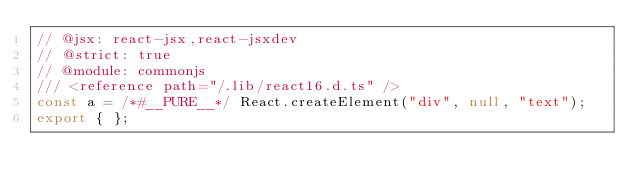<code> <loc_0><loc_0><loc_500><loc_500><_JavaScript_>// @jsx: react-jsx,react-jsxdev
// @strict: true
// @module: commonjs
/// <reference path="/.lib/react16.d.ts" />
const a = /*#__PURE__*/ React.createElement("div", null, "text");
export { };
</code> 